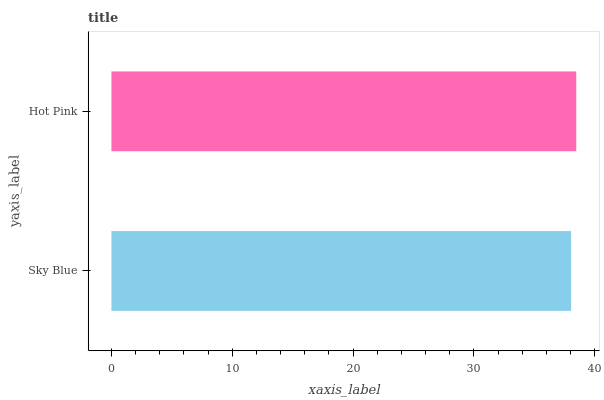Is Sky Blue the minimum?
Answer yes or no. Yes. Is Hot Pink the maximum?
Answer yes or no. Yes. Is Hot Pink the minimum?
Answer yes or no. No. Is Hot Pink greater than Sky Blue?
Answer yes or no. Yes. Is Sky Blue less than Hot Pink?
Answer yes or no. Yes. Is Sky Blue greater than Hot Pink?
Answer yes or no. No. Is Hot Pink less than Sky Blue?
Answer yes or no. No. Is Hot Pink the high median?
Answer yes or no. Yes. Is Sky Blue the low median?
Answer yes or no. Yes. Is Sky Blue the high median?
Answer yes or no. No. Is Hot Pink the low median?
Answer yes or no. No. 